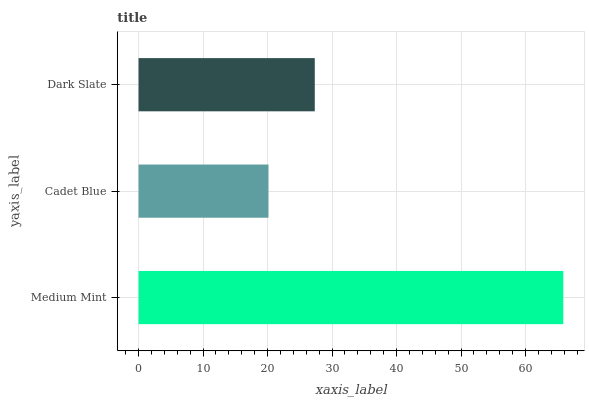Is Cadet Blue the minimum?
Answer yes or no. Yes. Is Medium Mint the maximum?
Answer yes or no. Yes. Is Dark Slate the minimum?
Answer yes or no. No. Is Dark Slate the maximum?
Answer yes or no. No. Is Dark Slate greater than Cadet Blue?
Answer yes or no. Yes. Is Cadet Blue less than Dark Slate?
Answer yes or no. Yes. Is Cadet Blue greater than Dark Slate?
Answer yes or no. No. Is Dark Slate less than Cadet Blue?
Answer yes or no. No. Is Dark Slate the high median?
Answer yes or no. Yes. Is Dark Slate the low median?
Answer yes or no. Yes. Is Medium Mint the high median?
Answer yes or no. No. Is Medium Mint the low median?
Answer yes or no. No. 